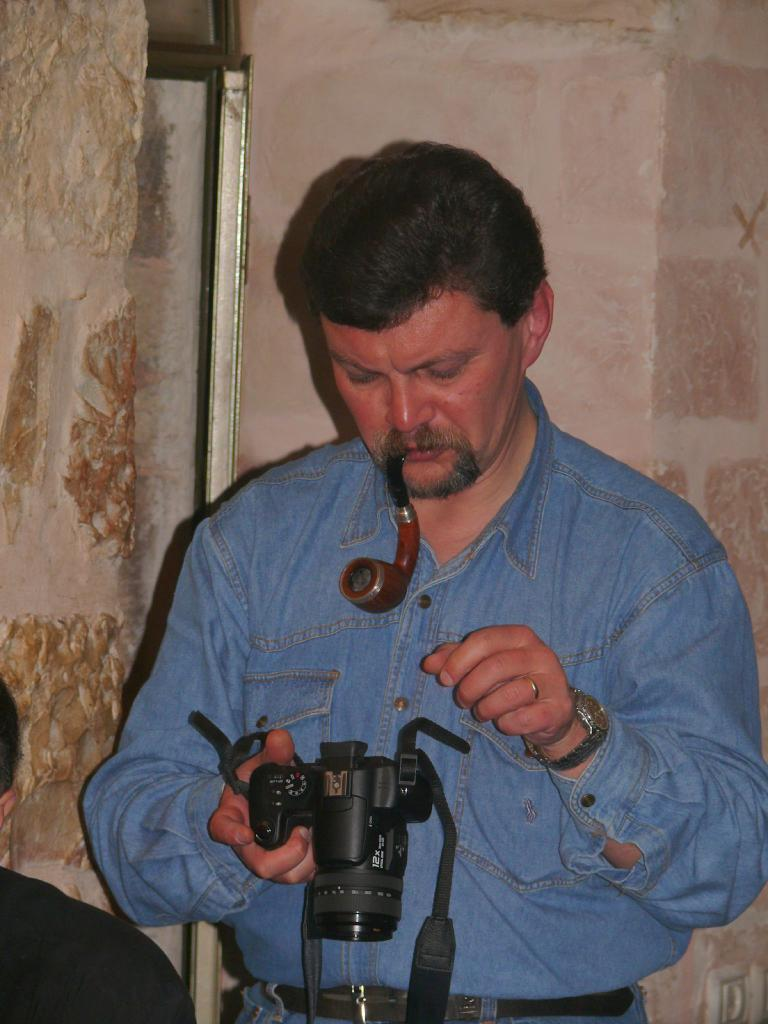What is the person in the image doing with their hands? The person is standing and holding a camera. What activity is the person engaged in? The person is smoking. Can you describe the position of the other person in the image? The other person is sitting. What can be seen in the background of the image? There is a wall in the background. What type of sweater is the rat wearing in the image? There is no rat or sweater present in the image. What is being exchanged between the two people in the image? There is no exchange of items or actions between the two people in the image. 